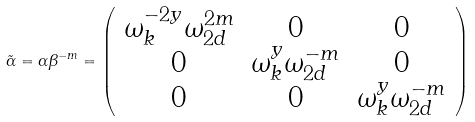<formula> <loc_0><loc_0><loc_500><loc_500>\tilde { \alpha } = \alpha \beta ^ { - m } = \left ( \begin{array} { c c c } \omega _ { k } ^ { - 2 y } \omega _ { 2 d } ^ { 2 m } & 0 & 0 \\ 0 & \omega _ { k } ^ { y } \omega _ { 2 d } ^ { - m } & 0 \\ 0 & 0 & \omega _ { k } ^ { y } \omega _ { 2 d } ^ { - m } \end{array} \right )</formula> 